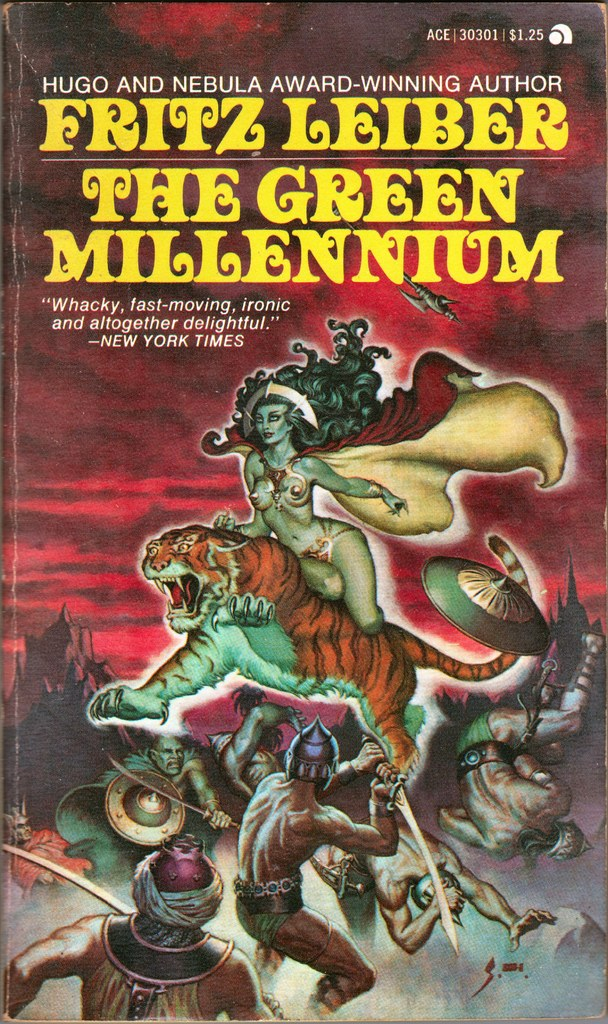How does the color scheme of the book cover affect the mood and perception of the story? The book cover’s use of intense, contrasting colors such as deep reds, greens, and yellows creates a vibrant and energetic mood, which hints at a story filled with adventure and conflict. Such a dynamic color palette may suggest a fast-paced, dramatic narrative, pulling the reader into a world where vivid visuals complement high stakes and emotional intensity. 